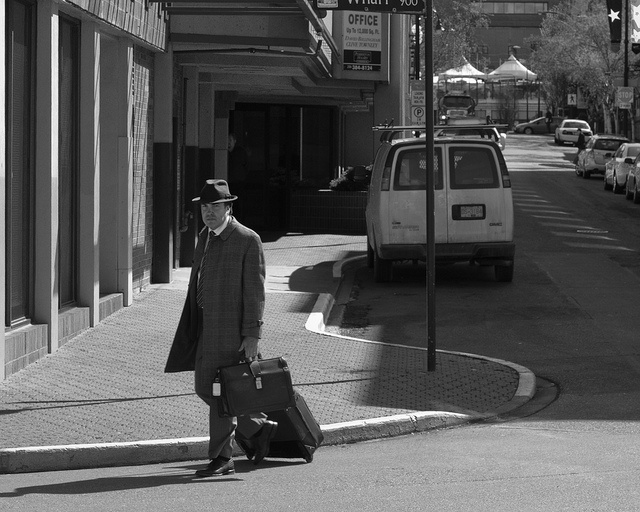Describe the objects in this image and their specific colors. I can see truck in white, black, gray, and lightgray tones, people in white, black, gray, darkgray, and lightgray tones, handbag in white, black, gray, darkgray, and lightgray tones, suitcase in black, gray, darkgray, and white tones, and car in white, gray, black, darkgray, and lightgray tones in this image. 